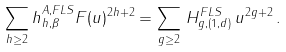<formula> <loc_0><loc_0><loc_500><loc_500>\sum _ { h \geq 2 } h ^ { A , F L S } _ { h , \beta } F ( u ) ^ { 2 h + 2 } = \sum _ { g \geq 2 } \, H ^ { F L S } _ { g , ( 1 , d ) } \, u ^ { 2 g + 2 } \, .</formula> 